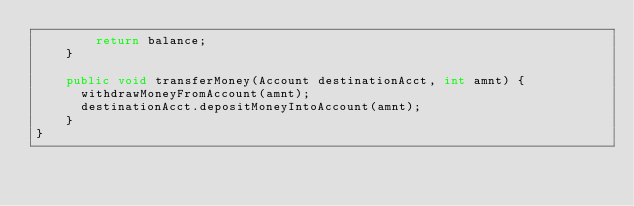Convert code to text. <code><loc_0><loc_0><loc_500><loc_500><_Java_>        return balance;
    }

    public void transferMoney(Account destinationAcct, int amnt) {
      withdrawMoneyFromAccount(amnt);
      destinationAcct.depositMoneyIntoAccount(amnt);
    }
}
</code> 